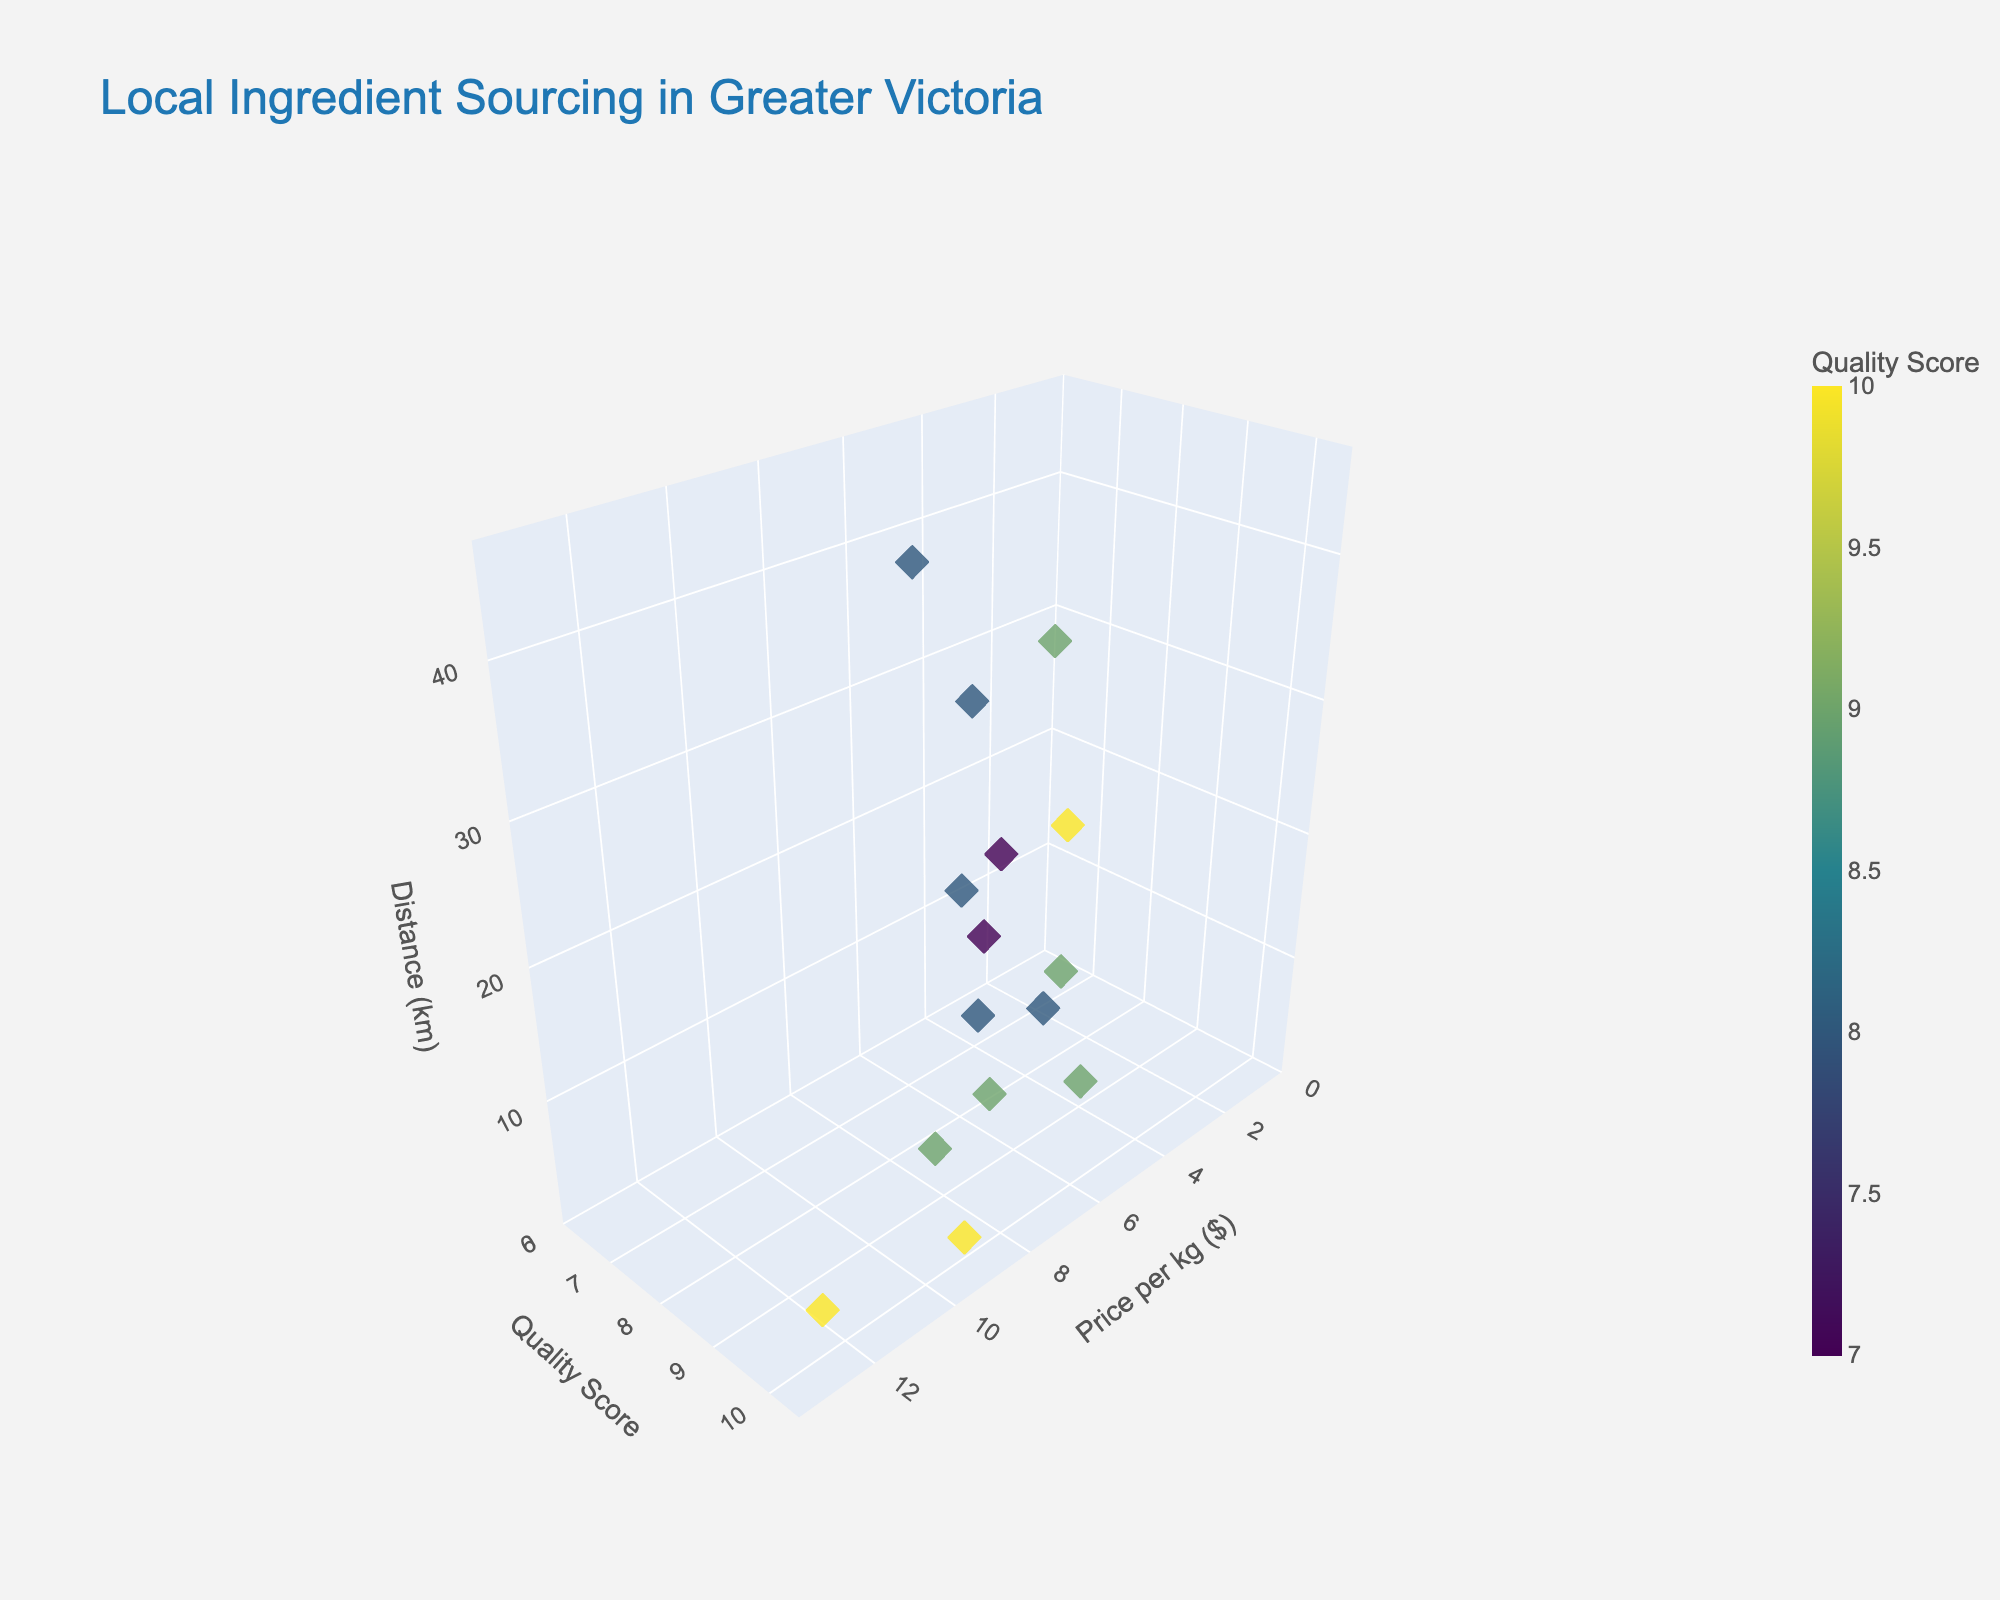What's the title of the plot? The title of the plot is found at the top center and it reads "Local Ingredient Sourcing in Greater Victoria". By observing the top part of the figure, one can easily identify the title.
Answer: Local Ingredient Sourcing in Greater Victoria What are the axis labels of the plot? The plot has three axes. The x-axis is labeled "Price per kg ($)", the y-axis is labeled "Quality Score", and the z-axis is labeled "Distance (km)". These labels are located next to their respective axes.
Answer: Price per kg ($), Quality Score, Distance (km) How many data points are shown in the plot? By counting the individual markers on the plot, we observe that there are a total of 15 data points representing 15 suppliers. Each marker corresponds to one supplier.
Answer: 15 Which supplier has the highest quality score, and what is its price per kg and distance from the bakery? By looking at the data point at the highest y-value (Quality Score of 10), we see that this corresponds to several suppliers, but by checking the individual data points, "Salt Spring Island Cheese", "Victoria Olive Oil Company", and "Silk Road Tea" are the suppliers all with a Quality Score of 10. Their price per kg and distances are $6.50, $12.50, and $9.00, and 28.3 km, 3.7 km, and 1.8 km respectively.
Answer: Salt Spring Island Cheese ($6.50, 28.3 km), Victoria Olive Oil Company ($12.50, 3.7 km), Silk Road Tea ($9.00, 1.8 km) What is the average price per kg of all the suppliers? To find the average price per kg, sum up all the prices and divide by the number of suppliers: (3.50 + 4.75 + 3.25 + 6.50 + 5.75 + 4.00 + 12.50 + 8.25 + 5.50 + 6.75 + 9.00 + 7.25 + 3.75 + 5.25 + 6.00) / 15 = 92.00 / 15 ≈ 6.13
Answer: 6.13 Which supplier has the shortest distance from the bakery, and what is its quality score and price per kg? By locating the supplier closest to the origin on the z-axis, we find that "Silk Road Tea" is the nearest supplier with a distance of 1.8 km. Their price per kg is $9.00, and their quality score is 10.
Answer: Silk Road Tea (10, $9.00) What is the range of quality scores represented in the plot? To find the range, identify the minimum and maximum values of the y-axis. The quality scores range from 7 to 10. Both values can be seen on the y-axis labels.
Answer: 7 to 10 Compare the distances of the two suppliers with the highest prices per kg. Which one is further? The two suppliers with the highest prices per kg are "Victoria Olive Oil Company" ($12.50) and "Silk Road Tea" ($9.00). "Victoria Olive Oil Company" is 3.7 km from the bakery, and "Silk Road Tea" is 1.8 km from the bakery. Thus, "Victoria Olive Oil Company" is further.
Answer: Victoria Olive Oil Company (3.7 km) Identify the supplier with the lowest quality score and compare its distance with the supplier having the highest price per kg. "Galey Farms" has the lowest quality score of 7. Its distance is 15.6 km. The supplier with the highest price per kg, "Victoria Olive Oil Company", has a distance of 3.7 km. Comparing the two, "Victoria Olive Oil Company" is closer to the bakery.
Answer: Victoria Olive Oil Company (3.7 km) is closer 